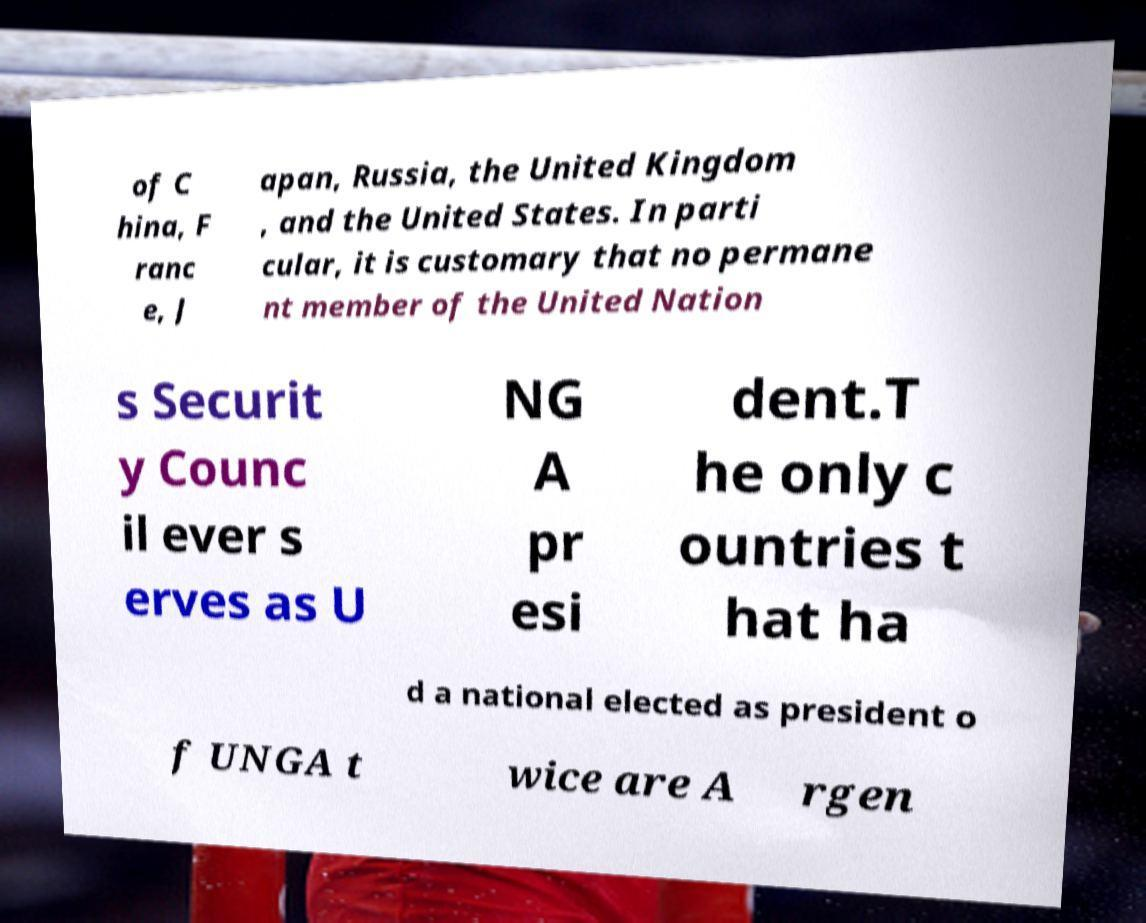Could you assist in decoding the text presented in this image and type it out clearly? of C hina, F ranc e, J apan, Russia, the United Kingdom , and the United States. In parti cular, it is customary that no permane nt member of the United Nation s Securit y Counc il ever s erves as U NG A pr esi dent.T he only c ountries t hat ha d a national elected as president o f UNGA t wice are A rgen 